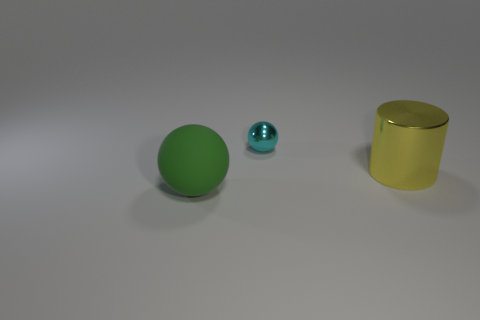Add 2 tiny cyan spheres. How many objects exist? 5 Subtract all blue cylinders. Subtract all cyan cubes. How many cylinders are left? 1 Subtract all balls. How many objects are left? 1 Add 2 cyan shiny spheres. How many cyan shiny spheres are left? 3 Add 1 large yellow cylinders. How many large yellow cylinders exist? 2 Subtract 0 red blocks. How many objects are left? 3 Subtract all big brown metal objects. Subtract all large rubber objects. How many objects are left? 2 